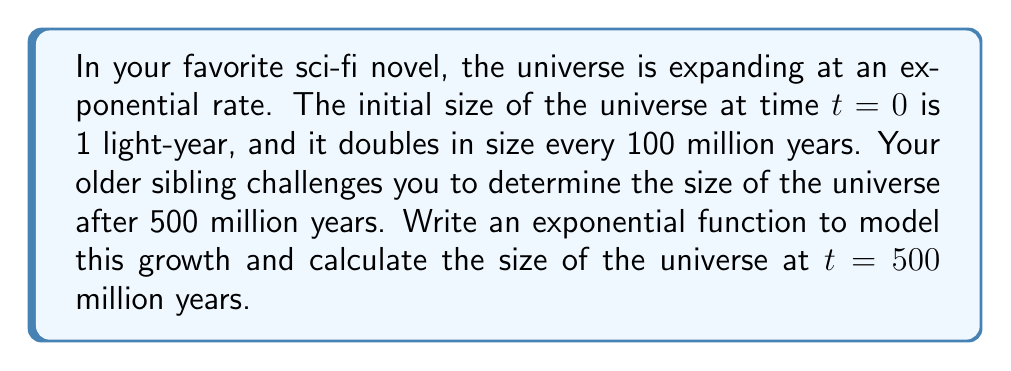Can you answer this question? Let's approach this step-by-step:

1) First, we need to identify the components of an exponential function:
   $$ f(t) = a \cdot b^t $$
   where $a$ is the initial value, $b$ is the growth factor, and $t$ is time.

2) We know:
   - Initial size ($a$) = 1 light-year
   - The size doubles every 100 million years
   - We need to find the size at $t = 500$ million years

3) To find $b$, we need to determine the growth factor per 1 million years:
   $$ b^{100} = 2 $$
   $$ b = 2^{\frac{1}{100}} \approx 1.007 $$

4) Now we can write our exponential function:
   $$ f(t) = 1 \cdot (1.007)^t $$
   where $t$ is measured in millions of years.

5) To find the size at 500 million years, we substitute $t = 500$:
   $$ f(500) = 1 \cdot (1.007)^{500} $$

6) Calculate this value:
   $$ f(500) \approx 32.03 $$

Therefore, after 500 million years, the universe will be approximately 32.03 light-years in size.
Answer: The size of the universe after 500 million years is approximately 32.03 light-years. 